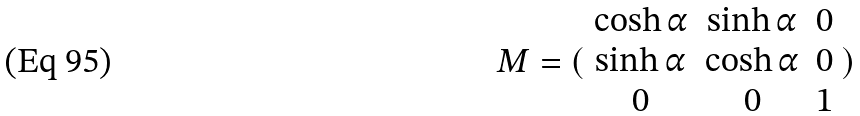Convert formula to latex. <formula><loc_0><loc_0><loc_500><loc_500>M = ( \begin{array} { c c c } \cosh \alpha & \sinh \alpha & 0 \\ \sinh \alpha & \cosh \alpha & 0 \\ 0 & 0 & 1 \end{array} )</formula> 